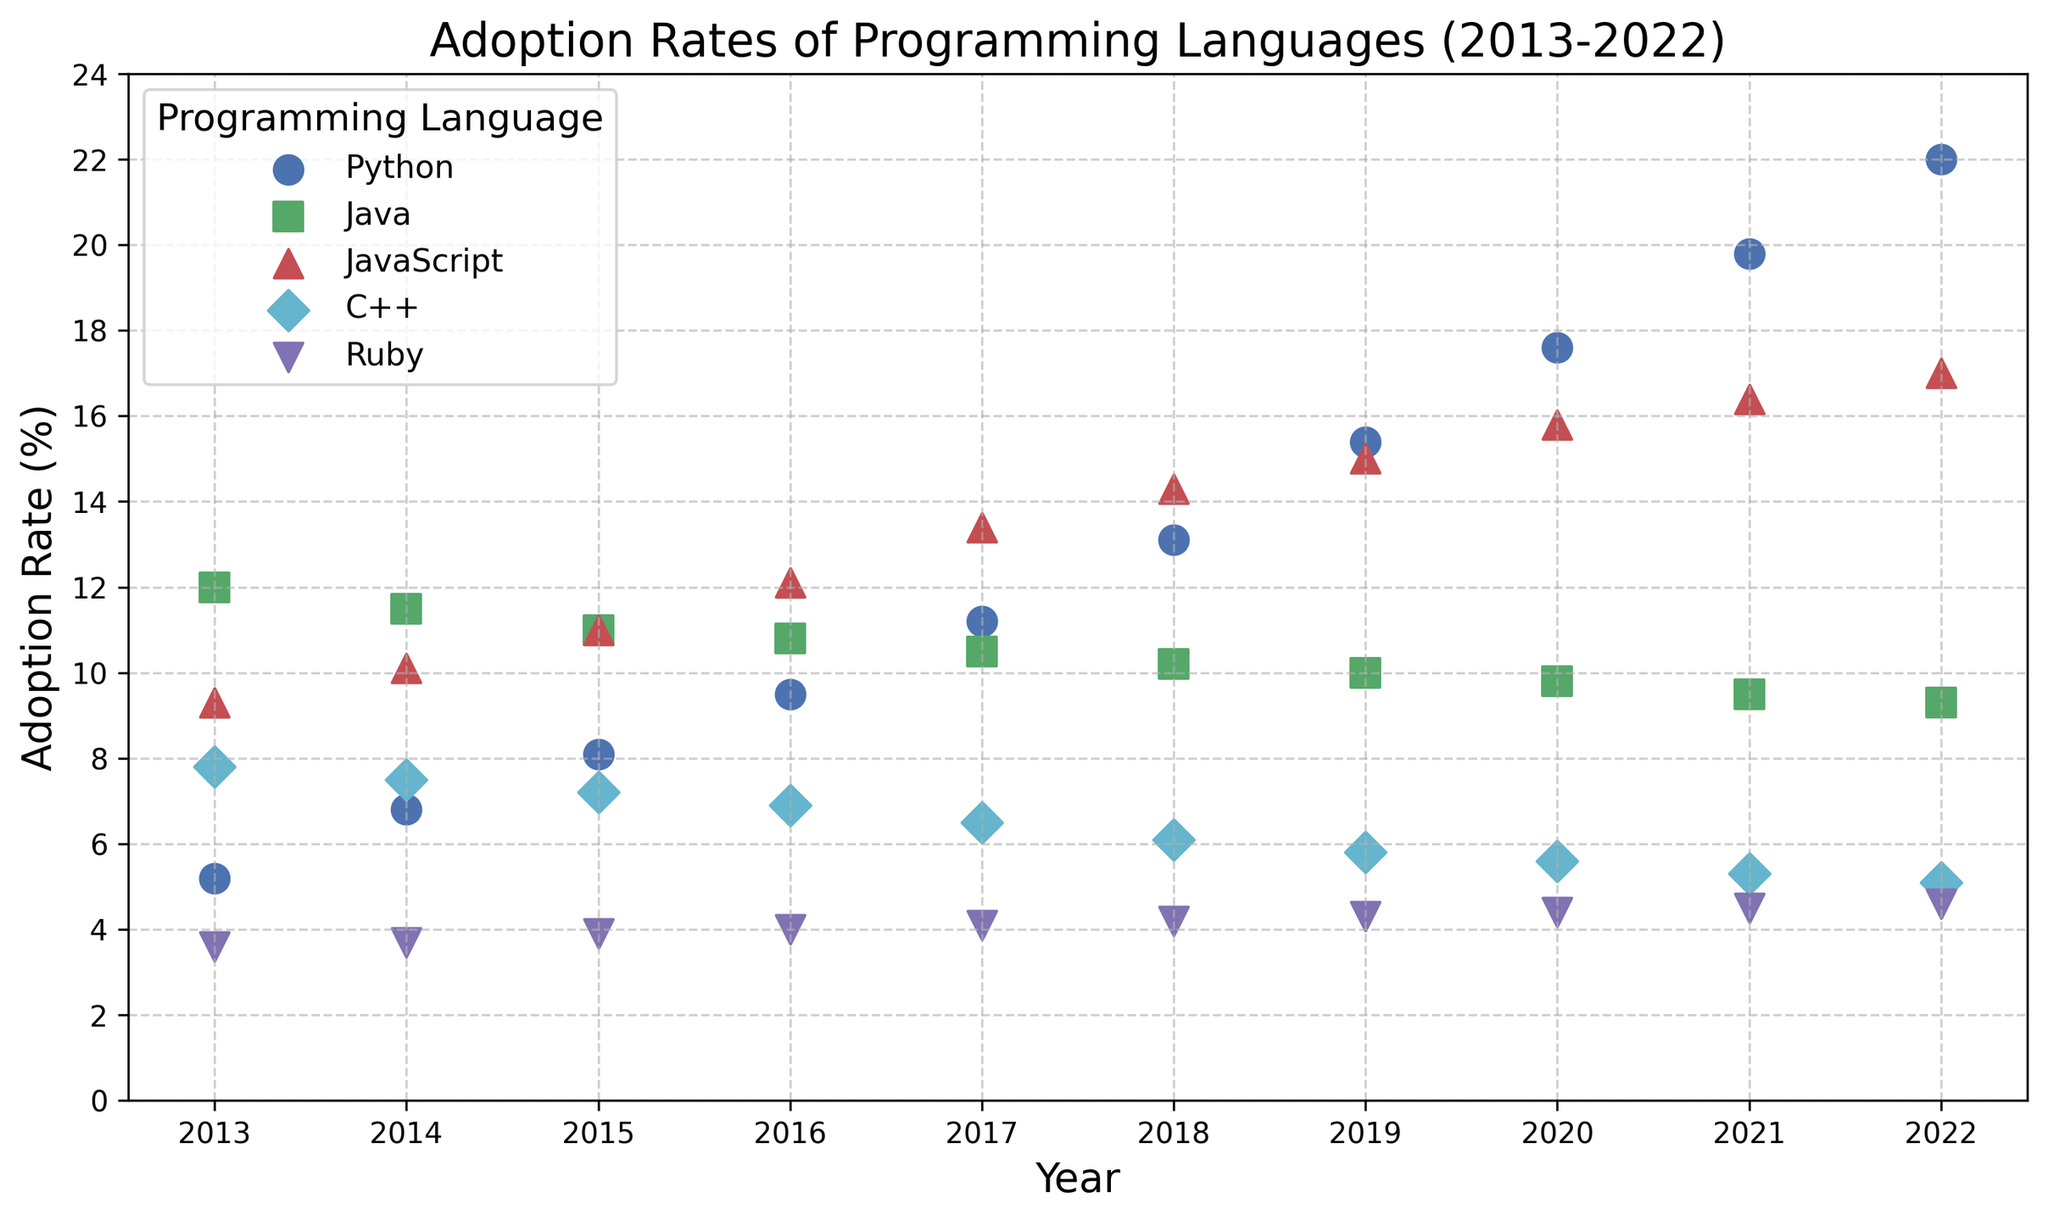What year did Python surpass Java in adoption rate, and by how much? First, find the year when Python's adoption rate first exceeded Java's rate. This happens in 2017. Then, find the rates for Python and Java in 2017, which are 11.2% and 10.5%, respectively. Finally, subtract Java's rate from Python's rate.
Answer: 2017, by 0.7% Which language had the highest adoption rate in 2016, and what was the value? Identify the adoption rates for all languages in 2016. The rates are: Python (9.5%), Java (10.8%), JavaScript (12.1%), C++ (6.9%), and Ruby (4.0%). Among these, JavaScript has the highest adoption rate.
Answer: JavaScript, 12.1% How did the adoption rate of Ruby change from 2013 to 2022? Find Ruby's adoption rate in 2013 (3.6%) and in 2022 (4.6%). Calculate the change by subtracting the 2013 rate from the 2022 rate.
Answer: Increased by 1.0% Compare the trend of adoption rates for Python and C++ over the decade. Look at the trends for Python and C++ from 2013 to 2022. Python's adoption rate increases steadily from 5.2% to 22.0%. In contrast, C++'s rate consistently decreases from 7.8% to 5.1%.
Answer: Python increased, C++ decreased What is the average adoption rate of JavaScript from 2013 to 2022? Sum the adoption rates of JavaScript from 2013 to 2022 and divide by the number of years (10). The rates are: 9.3, 10.1, 11.0, 12.1, 13.4, 14.3, 15.0, 15.8, 16.4, 17.0. The sum is 134.4%, and the average is 134.4 / 10.
Answer: 13.44% In which year did JavaScript have the largest increase in adoption rate compared to the previous year? Calculate the year-over-year change for JavaScript's adoption rate and identify the largest increase. The changes are: 2014 (0.8%), 2015 (0.9%), 2016 (1.1%), 2017 (1.3%), 2018 (0.9%), 2019 (0.7%), 2020 (0.8%), 2021 (0.6%), 2022 (0.6%). The largest increase is from 2016 to 2017.
Answer: 2017 By how much did C++'s adoption rate decrease from its highest point in the decade to its lowest point? Find C++'s highest adoption rate (7.8% in 2013) and its lowest (5.1% in 2022). Subtract the lowest rate from the highest rate.
Answer: Decreased by 2.7% Which language had the smallest variance in adoption rate over the decade? Compare the variance in adoption rates for all the languages. Calculate variances for Python, Java, JavaScript, C++, and Ruby. Based on the visual data, Ruby shows the least fluctuation.
Answer: Ruby 